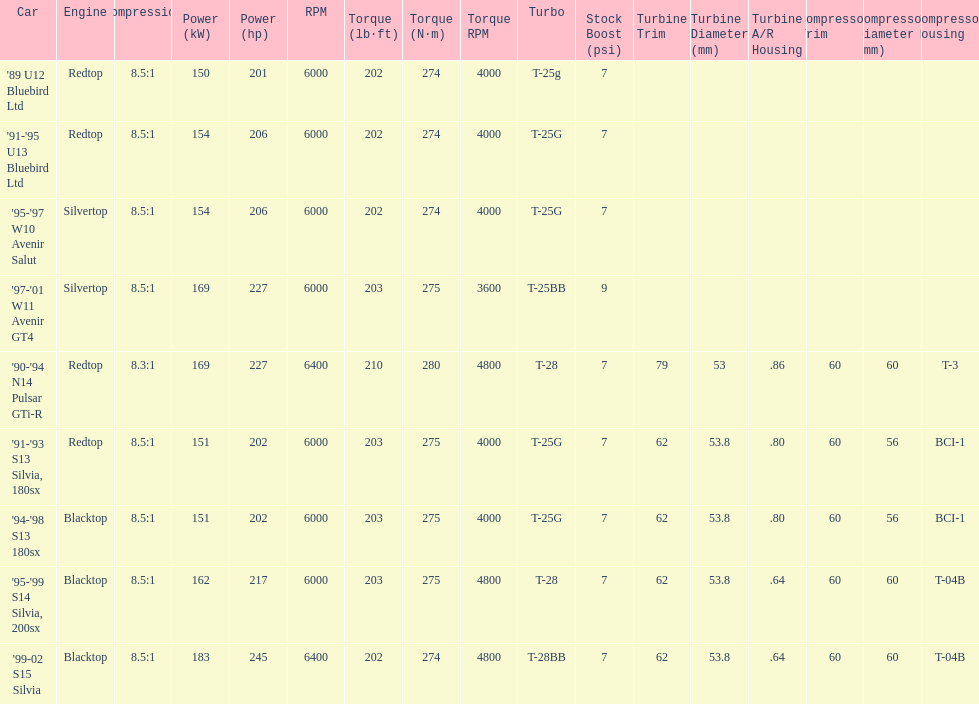Which car has a stock boost of over 7psi? '97-'01 W11 Avenir GT4. 